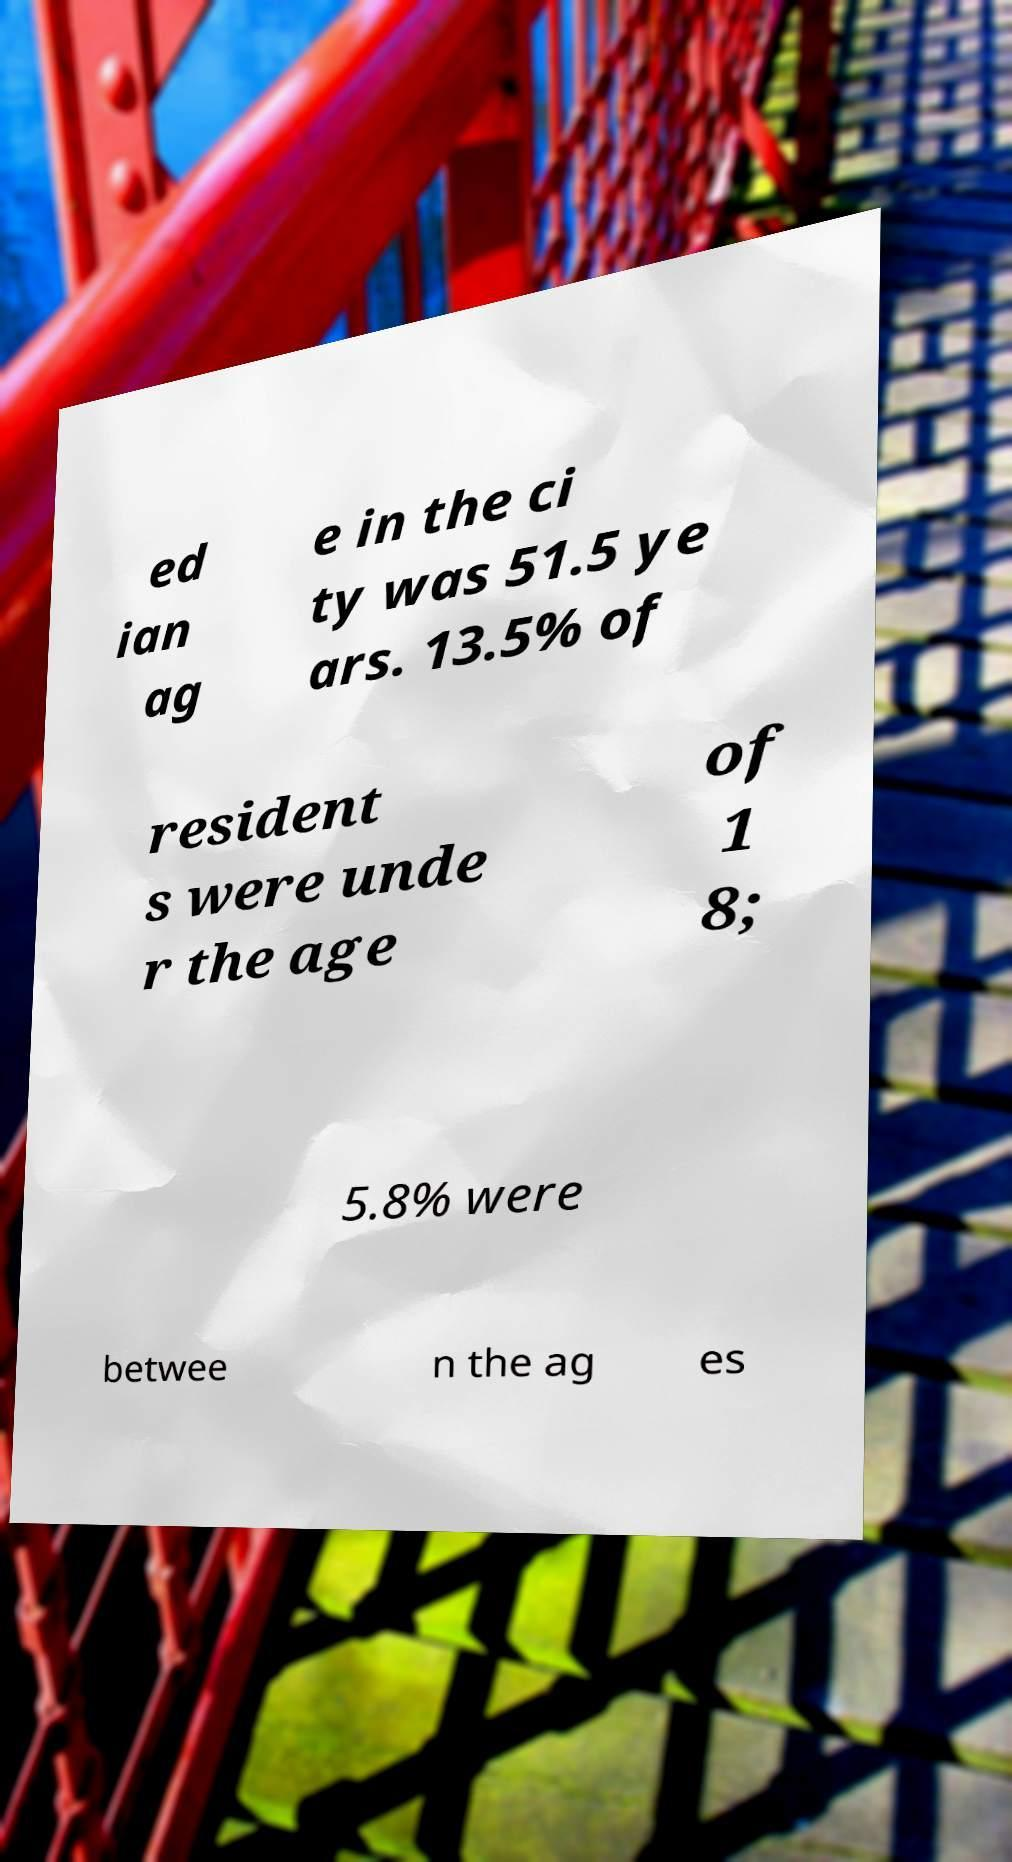There's text embedded in this image that I need extracted. Can you transcribe it verbatim? ed ian ag e in the ci ty was 51.5 ye ars. 13.5% of resident s were unde r the age of 1 8; 5.8% were betwee n the ag es 